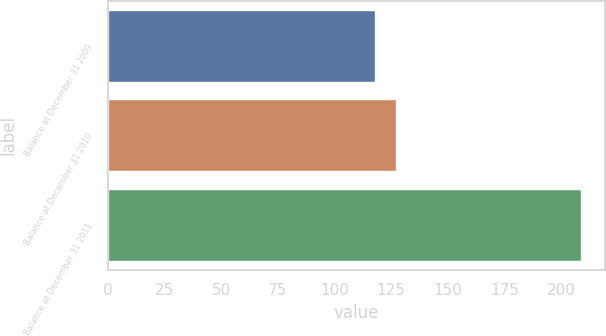Convert chart to OTSL. <chart><loc_0><loc_0><loc_500><loc_500><bar_chart><fcel>Balance at December 31 2009<fcel>Balance at December 31 2010<fcel>Balance at December 31 2011<nl><fcel>118<fcel>127.1<fcel>209<nl></chart> 